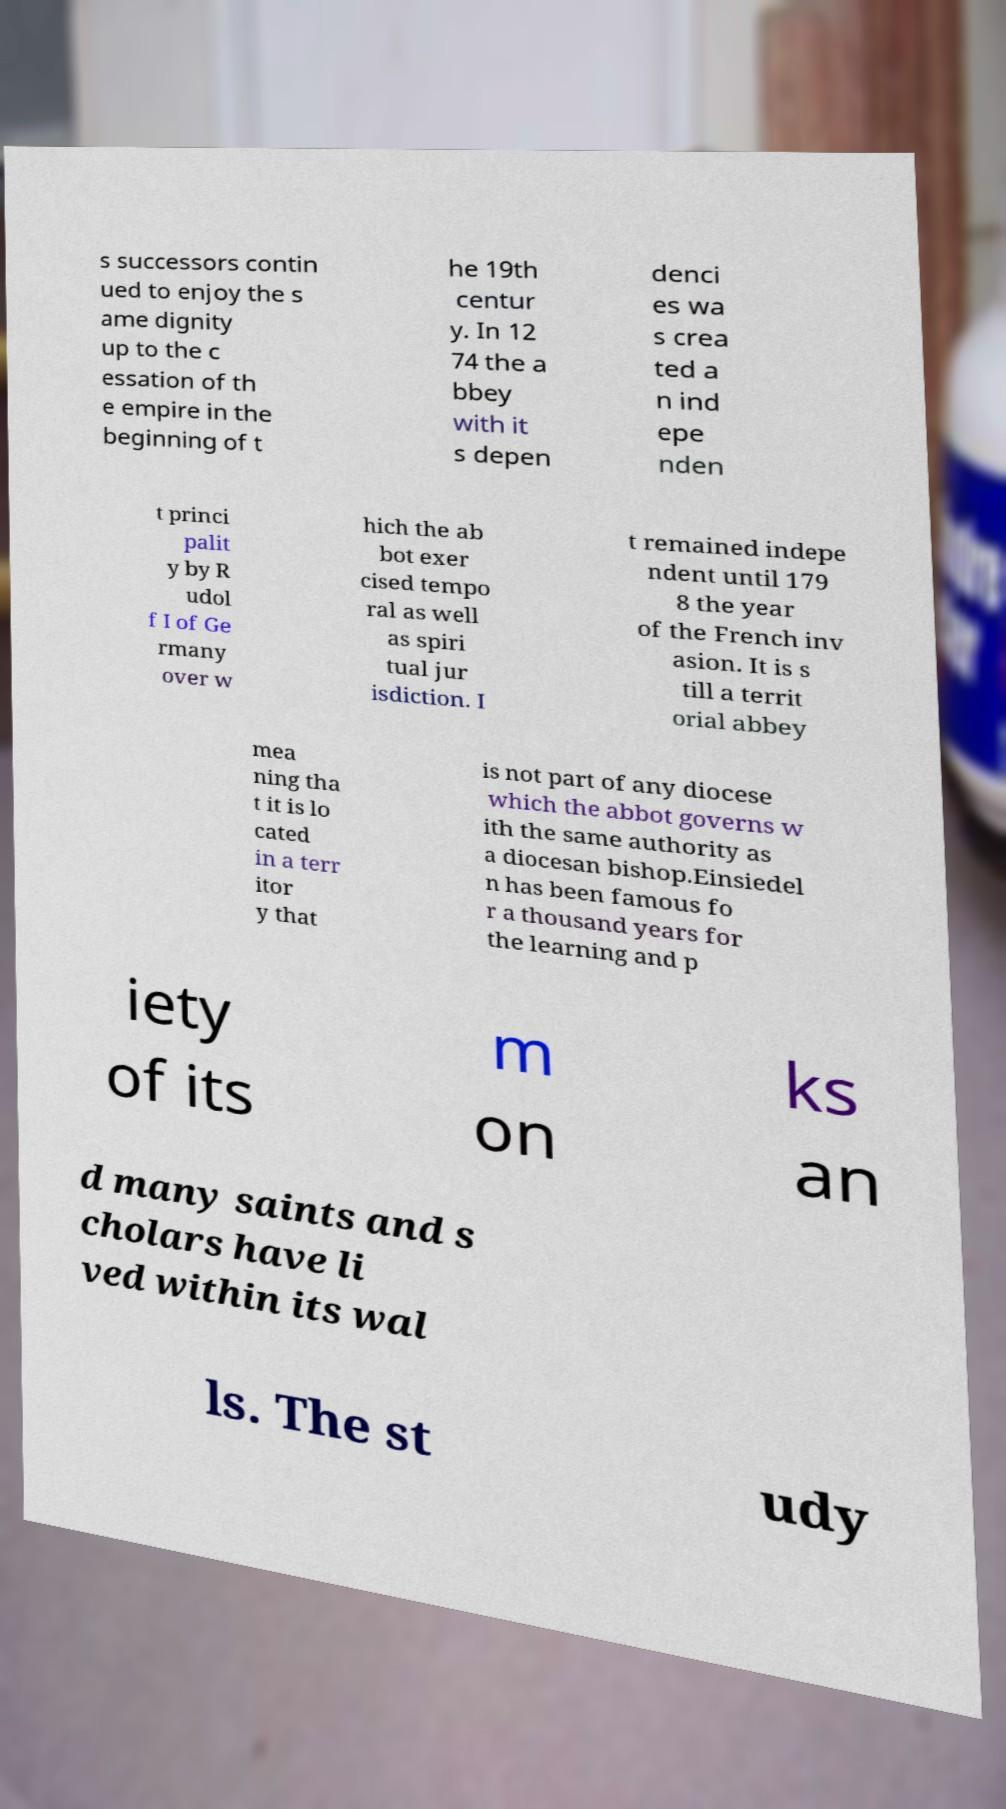Could you extract and type out the text from this image? s successors contin ued to enjoy the s ame dignity up to the c essation of th e empire in the beginning of t he 19th centur y. In 12 74 the a bbey with it s depen denci es wa s crea ted a n ind epe nden t princi palit y by R udol f I of Ge rmany over w hich the ab bot exer cised tempo ral as well as spiri tual jur isdiction. I t remained indepe ndent until 179 8 the year of the French inv asion. It is s till a territ orial abbey mea ning tha t it is lo cated in a terr itor y that is not part of any diocese which the abbot governs w ith the same authority as a diocesan bishop.Einsiedel n has been famous fo r a thousand years for the learning and p iety of its m on ks an d many saints and s cholars have li ved within its wal ls. The st udy 